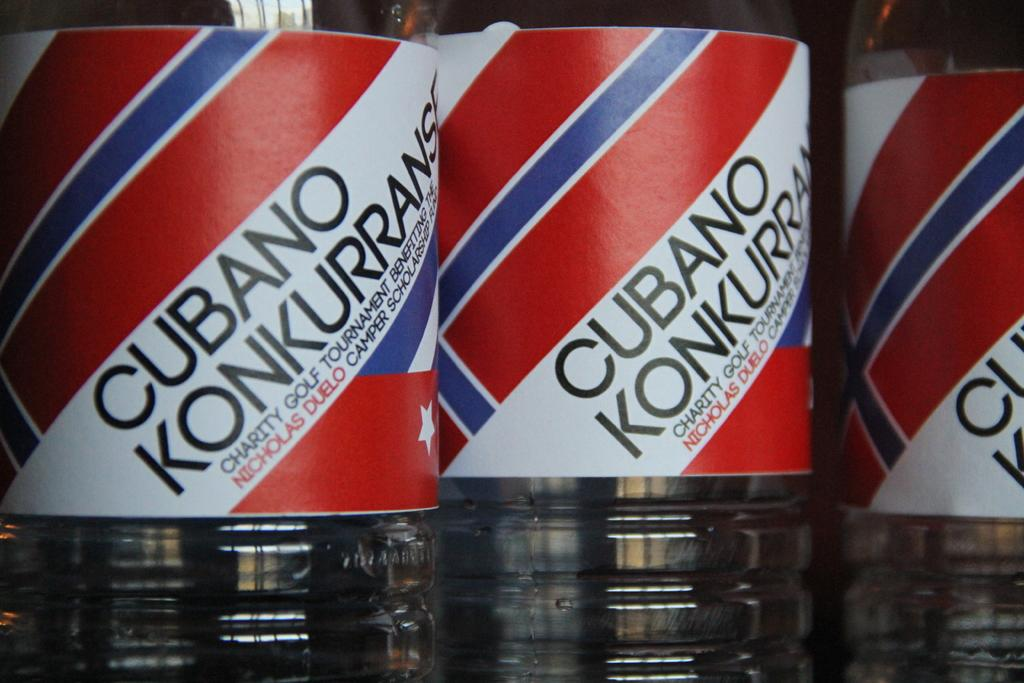<image>
Offer a succinct explanation of the picture presented. A row of bottles with red, blue, and white labels that say Cubano Konkurrans. 